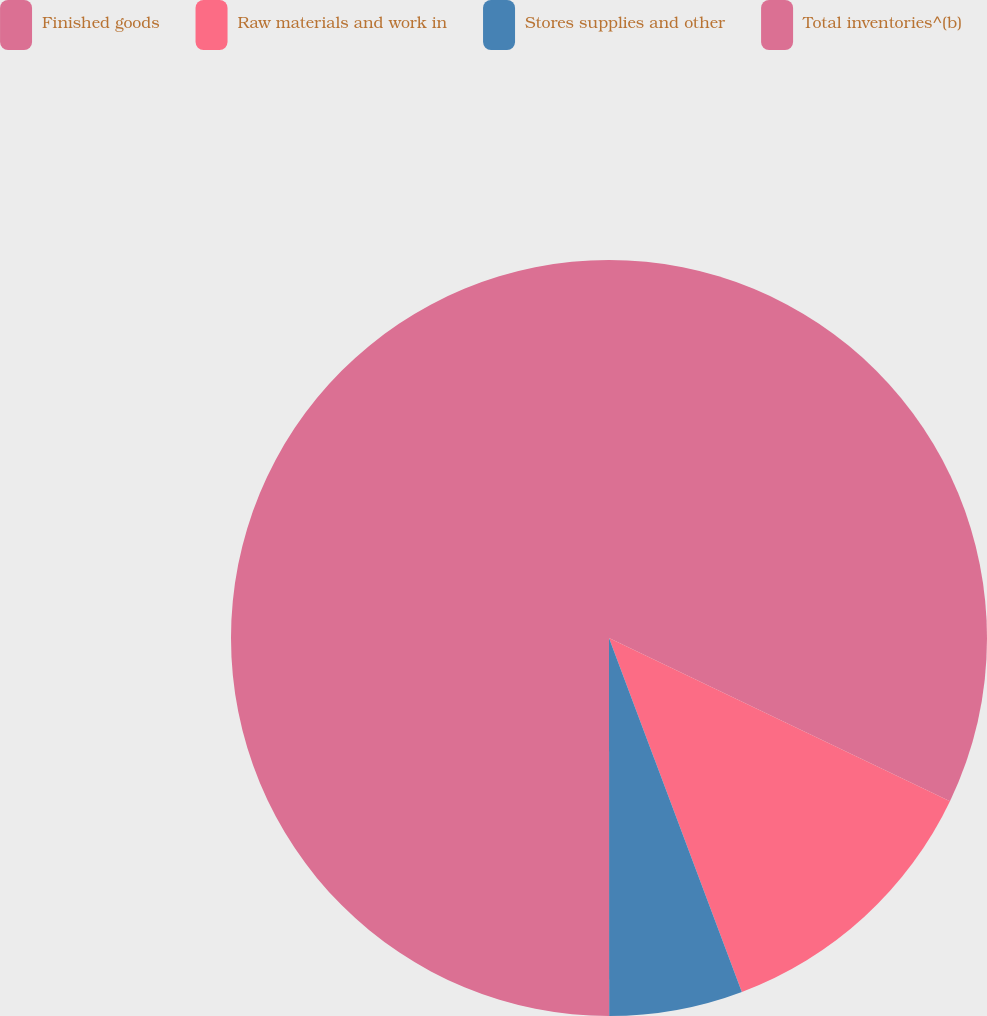Convert chart to OTSL. <chart><loc_0><loc_0><loc_500><loc_500><pie_chart><fcel>Finished goods<fcel>Raw materials and work in<fcel>Stores supplies and other<fcel>Total inventories^(b)<nl><fcel>32.1%<fcel>12.18%<fcel>5.71%<fcel>50.0%<nl></chart> 